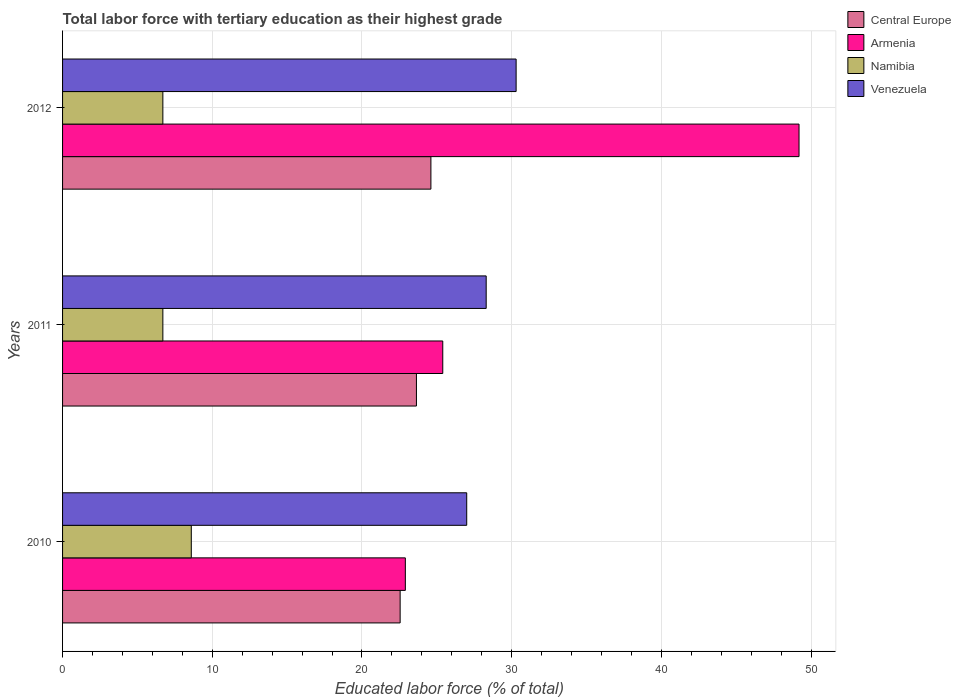How many groups of bars are there?
Keep it short and to the point. 3. Are the number of bars on each tick of the Y-axis equal?
Your answer should be very brief. Yes. What is the label of the 3rd group of bars from the top?
Offer a terse response. 2010. What is the percentage of male labor force with tertiary education in Central Europe in 2012?
Provide a succinct answer. 24.61. Across all years, what is the maximum percentage of male labor force with tertiary education in Armenia?
Make the answer very short. 49.2. Across all years, what is the minimum percentage of male labor force with tertiary education in Armenia?
Give a very brief answer. 22.9. In which year was the percentage of male labor force with tertiary education in Venezuela maximum?
Your response must be concise. 2012. In which year was the percentage of male labor force with tertiary education in Venezuela minimum?
Give a very brief answer. 2010. What is the total percentage of male labor force with tertiary education in Armenia in the graph?
Your response must be concise. 97.5. What is the difference between the percentage of male labor force with tertiary education in Central Europe in 2010 and that in 2012?
Your answer should be very brief. -2.06. What is the difference between the percentage of male labor force with tertiary education in Armenia in 2010 and the percentage of male labor force with tertiary education in Central Europe in 2011?
Ensure brevity in your answer.  -0.74. What is the average percentage of male labor force with tertiary education in Namibia per year?
Give a very brief answer. 7.33. In the year 2010, what is the difference between the percentage of male labor force with tertiary education in Central Europe and percentage of male labor force with tertiary education in Venezuela?
Make the answer very short. -4.45. In how many years, is the percentage of male labor force with tertiary education in Armenia greater than 40 %?
Provide a succinct answer. 1. What is the ratio of the percentage of male labor force with tertiary education in Venezuela in 2010 to that in 2011?
Offer a very short reply. 0.95. What is the difference between the highest and the second highest percentage of male labor force with tertiary education in Namibia?
Offer a very short reply. 1.9. What is the difference between the highest and the lowest percentage of male labor force with tertiary education in Armenia?
Provide a succinct answer. 26.3. In how many years, is the percentage of male labor force with tertiary education in Armenia greater than the average percentage of male labor force with tertiary education in Armenia taken over all years?
Ensure brevity in your answer.  1. Is it the case that in every year, the sum of the percentage of male labor force with tertiary education in Venezuela and percentage of male labor force with tertiary education in Central Europe is greater than the sum of percentage of male labor force with tertiary education in Armenia and percentage of male labor force with tertiary education in Namibia?
Your response must be concise. No. What does the 3rd bar from the top in 2012 represents?
Provide a short and direct response. Armenia. What does the 1st bar from the bottom in 2010 represents?
Offer a terse response. Central Europe. Is it the case that in every year, the sum of the percentage of male labor force with tertiary education in Namibia and percentage of male labor force with tertiary education in Armenia is greater than the percentage of male labor force with tertiary education in Central Europe?
Offer a terse response. Yes. How many bars are there?
Offer a terse response. 12. Are all the bars in the graph horizontal?
Make the answer very short. Yes. Are the values on the major ticks of X-axis written in scientific E-notation?
Give a very brief answer. No. Does the graph contain any zero values?
Offer a terse response. No. How are the legend labels stacked?
Your answer should be very brief. Vertical. What is the title of the graph?
Ensure brevity in your answer.  Total labor force with tertiary education as their highest grade. Does "Liechtenstein" appear as one of the legend labels in the graph?
Offer a terse response. No. What is the label or title of the X-axis?
Keep it short and to the point. Educated labor force (% of total). What is the Educated labor force (% of total) of Central Europe in 2010?
Make the answer very short. 22.55. What is the Educated labor force (% of total) in Armenia in 2010?
Your response must be concise. 22.9. What is the Educated labor force (% of total) of Namibia in 2010?
Provide a short and direct response. 8.6. What is the Educated labor force (% of total) of Venezuela in 2010?
Your response must be concise. 27. What is the Educated labor force (% of total) of Central Europe in 2011?
Your response must be concise. 23.64. What is the Educated labor force (% of total) of Armenia in 2011?
Offer a terse response. 25.4. What is the Educated labor force (% of total) of Namibia in 2011?
Keep it short and to the point. 6.7. What is the Educated labor force (% of total) in Venezuela in 2011?
Offer a terse response. 28.3. What is the Educated labor force (% of total) in Central Europe in 2012?
Offer a terse response. 24.61. What is the Educated labor force (% of total) of Armenia in 2012?
Your answer should be very brief. 49.2. What is the Educated labor force (% of total) in Namibia in 2012?
Make the answer very short. 6.7. What is the Educated labor force (% of total) in Venezuela in 2012?
Your response must be concise. 30.3. Across all years, what is the maximum Educated labor force (% of total) in Central Europe?
Keep it short and to the point. 24.61. Across all years, what is the maximum Educated labor force (% of total) of Armenia?
Give a very brief answer. 49.2. Across all years, what is the maximum Educated labor force (% of total) in Namibia?
Make the answer very short. 8.6. Across all years, what is the maximum Educated labor force (% of total) in Venezuela?
Give a very brief answer. 30.3. Across all years, what is the minimum Educated labor force (% of total) in Central Europe?
Ensure brevity in your answer.  22.55. Across all years, what is the minimum Educated labor force (% of total) of Armenia?
Offer a terse response. 22.9. Across all years, what is the minimum Educated labor force (% of total) in Namibia?
Your answer should be compact. 6.7. Across all years, what is the minimum Educated labor force (% of total) in Venezuela?
Your answer should be very brief. 27. What is the total Educated labor force (% of total) of Central Europe in the graph?
Offer a terse response. 70.8. What is the total Educated labor force (% of total) in Armenia in the graph?
Keep it short and to the point. 97.5. What is the total Educated labor force (% of total) of Venezuela in the graph?
Give a very brief answer. 85.6. What is the difference between the Educated labor force (% of total) in Central Europe in 2010 and that in 2011?
Ensure brevity in your answer.  -1.09. What is the difference between the Educated labor force (% of total) in Armenia in 2010 and that in 2011?
Ensure brevity in your answer.  -2.5. What is the difference between the Educated labor force (% of total) in Namibia in 2010 and that in 2011?
Your answer should be very brief. 1.9. What is the difference between the Educated labor force (% of total) in Venezuela in 2010 and that in 2011?
Your response must be concise. -1.3. What is the difference between the Educated labor force (% of total) of Central Europe in 2010 and that in 2012?
Provide a succinct answer. -2.06. What is the difference between the Educated labor force (% of total) of Armenia in 2010 and that in 2012?
Provide a succinct answer. -26.3. What is the difference between the Educated labor force (% of total) of Namibia in 2010 and that in 2012?
Ensure brevity in your answer.  1.9. What is the difference between the Educated labor force (% of total) in Venezuela in 2010 and that in 2012?
Give a very brief answer. -3.3. What is the difference between the Educated labor force (% of total) of Central Europe in 2011 and that in 2012?
Your answer should be compact. -0.97. What is the difference between the Educated labor force (% of total) in Armenia in 2011 and that in 2012?
Provide a short and direct response. -23.8. What is the difference between the Educated labor force (% of total) of Venezuela in 2011 and that in 2012?
Provide a short and direct response. -2. What is the difference between the Educated labor force (% of total) in Central Europe in 2010 and the Educated labor force (% of total) in Armenia in 2011?
Provide a short and direct response. -2.85. What is the difference between the Educated labor force (% of total) of Central Europe in 2010 and the Educated labor force (% of total) of Namibia in 2011?
Your response must be concise. 15.85. What is the difference between the Educated labor force (% of total) of Central Europe in 2010 and the Educated labor force (% of total) of Venezuela in 2011?
Offer a very short reply. -5.75. What is the difference between the Educated labor force (% of total) of Armenia in 2010 and the Educated labor force (% of total) of Namibia in 2011?
Provide a succinct answer. 16.2. What is the difference between the Educated labor force (% of total) in Armenia in 2010 and the Educated labor force (% of total) in Venezuela in 2011?
Your answer should be very brief. -5.4. What is the difference between the Educated labor force (% of total) of Namibia in 2010 and the Educated labor force (% of total) of Venezuela in 2011?
Give a very brief answer. -19.7. What is the difference between the Educated labor force (% of total) in Central Europe in 2010 and the Educated labor force (% of total) in Armenia in 2012?
Your answer should be very brief. -26.65. What is the difference between the Educated labor force (% of total) in Central Europe in 2010 and the Educated labor force (% of total) in Namibia in 2012?
Your answer should be compact. 15.85. What is the difference between the Educated labor force (% of total) of Central Europe in 2010 and the Educated labor force (% of total) of Venezuela in 2012?
Provide a succinct answer. -7.75. What is the difference between the Educated labor force (% of total) of Armenia in 2010 and the Educated labor force (% of total) of Venezuela in 2012?
Keep it short and to the point. -7.4. What is the difference between the Educated labor force (% of total) of Namibia in 2010 and the Educated labor force (% of total) of Venezuela in 2012?
Provide a succinct answer. -21.7. What is the difference between the Educated labor force (% of total) in Central Europe in 2011 and the Educated labor force (% of total) in Armenia in 2012?
Keep it short and to the point. -25.56. What is the difference between the Educated labor force (% of total) of Central Europe in 2011 and the Educated labor force (% of total) of Namibia in 2012?
Give a very brief answer. 16.94. What is the difference between the Educated labor force (% of total) of Central Europe in 2011 and the Educated labor force (% of total) of Venezuela in 2012?
Give a very brief answer. -6.66. What is the difference between the Educated labor force (% of total) of Armenia in 2011 and the Educated labor force (% of total) of Venezuela in 2012?
Your response must be concise. -4.9. What is the difference between the Educated labor force (% of total) of Namibia in 2011 and the Educated labor force (% of total) of Venezuela in 2012?
Offer a terse response. -23.6. What is the average Educated labor force (% of total) of Central Europe per year?
Offer a terse response. 23.6. What is the average Educated labor force (% of total) in Armenia per year?
Ensure brevity in your answer.  32.5. What is the average Educated labor force (% of total) of Namibia per year?
Offer a very short reply. 7.33. What is the average Educated labor force (% of total) in Venezuela per year?
Provide a succinct answer. 28.53. In the year 2010, what is the difference between the Educated labor force (% of total) in Central Europe and Educated labor force (% of total) in Armenia?
Keep it short and to the point. -0.35. In the year 2010, what is the difference between the Educated labor force (% of total) in Central Europe and Educated labor force (% of total) in Namibia?
Your response must be concise. 13.95. In the year 2010, what is the difference between the Educated labor force (% of total) of Central Europe and Educated labor force (% of total) of Venezuela?
Keep it short and to the point. -4.45. In the year 2010, what is the difference between the Educated labor force (% of total) of Armenia and Educated labor force (% of total) of Namibia?
Your answer should be compact. 14.3. In the year 2010, what is the difference between the Educated labor force (% of total) in Namibia and Educated labor force (% of total) in Venezuela?
Your answer should be compact. -18.4. In the year 2011, what is the difference between the Educated labor force (% of total) of Central Europe and Educated labor force (% of total) of Armenia?
Ensure brevity in your answer.  -1.76. In the year 2011, what is the difference between the Educated labor force (% of total) in Central Europe and Educated labor force (% of total) in Namibia?
Offer a terse response. 16.94. In the year 2011, what is the difference between the Educated labor force (% of total) in Central Europe and Educated labor force (% of total) in Venezuela?
Ensure brevity in your answer.  -4.66. In the year 2011, what is the difference between the Educated labor force (% of total) in Namibia and Educated labor force (% of total) in Venezuela?
Offer a terse response. -21.6. In the year 2012, what is the difference between the Educated labor force (% of total) of Central Europe and Educated labor force (% of total) of Armenia?
Provide a succinct answer. -24.59. In the year 2012, what is the difference between the Educated labor force (% of total) in Central Europe and Educated labor force (% of total) in Namibia?
Provide a succinct answer. 17.91. In the year 2012, what is the difference between the Educated labor force (% of total) of Central Europe and Educated labor force (% of total) of Venezuela?
Keep it short and to the point. -5.69. In the year 2012, what is the difference between the Educated labor force (% of total) of Armenia and Educated labor force (% of total) of Namibia?
Your answer should be very brief. 42.5. In the year 2012, what is the difference between the Educated labor force (% of total) in Armenia and Educated labor force (% of total) in Venezuela?
Your response must be concise. 18.9. In the year 2012, what is the difference between the Educated labor force (% of total) of Namibia and Educated labor force (% of total) of Venezuela?
Provide a succinct answer. -23.6. What is the ratio of the Educated labor force (% of total) in Central Europe in 2010 to that in 2011?
Make the answer very short. 0.95. What is the ratio of the Educated labor force (% of total) in Armenia in 2010 to that in 2011?
Provide a succinct answer. 0.9. What is the ratio of the Educated labor force (% of total) of Namibia in 2010 to that in 2011?
Your answer should be compact. 1.28. What is the ratio of the Educated labor force (% of total) of Venezuela in 2010 to that in 2011?
Keep it short and to the point. 0.95. What is the ratio of the Educated labor force (% of total) in Central Europe in 2010 to that in 2012?
Ensure brevity in your answer.  0.92. What is the ratio of the Educated labor force (% of total) of Armenia in 2010 to that in 2012?
Give a very brief answer. 0.47. What is the ratio of the Educated labor force (% of total) of Namibia in 2010 to that in 2012?
Give a very brief answer. 1.28. What is the ratio of the Educated labor force (% of total) of Venezuela in 2010 to that in 2012?
Provide a succinct answer. 0.89. What is the ratio of the Educated labor force (% of total) in Central Europe in 2011 to that in 2012?
Your response must be concise. 0.96. What is the ratio of the Educated labor force (% of total) in Armenia in 2011 to that in 2012?
Provide a succinct answer. 0.52. What is the ratio of the Educated labor force (% of total) of Venezuela in 2011 to that in 2012?
Ensure brevity in your answer.  0.93. What is the difference between the highest and the second highest Educated labor force (% of total) of Central Europe?
Offer a terse response. 0.97. What is the difference between the highest and the second highest Educated labor force (% of total) in Armenia?
Provide a short and direct response. 23.8. What is the difference between the highest and the lowest Educated labor force (% of total) in Central Europe?
Your answer should be very brief. 2.06. What is the difference between the highest and the lowest Educated labor force (% of total) in Armenia?
Keep it short and to the point. 26.3. What is the difference between the highest and the lowest Educated labor force (% of total) of Namibia?
Ensure brevity in your answer.  1.9. What is the difference between the highest and the lowest Educated labor force (% of total) of Venezuela?
Ensure brevity in your answer.  3.3. 